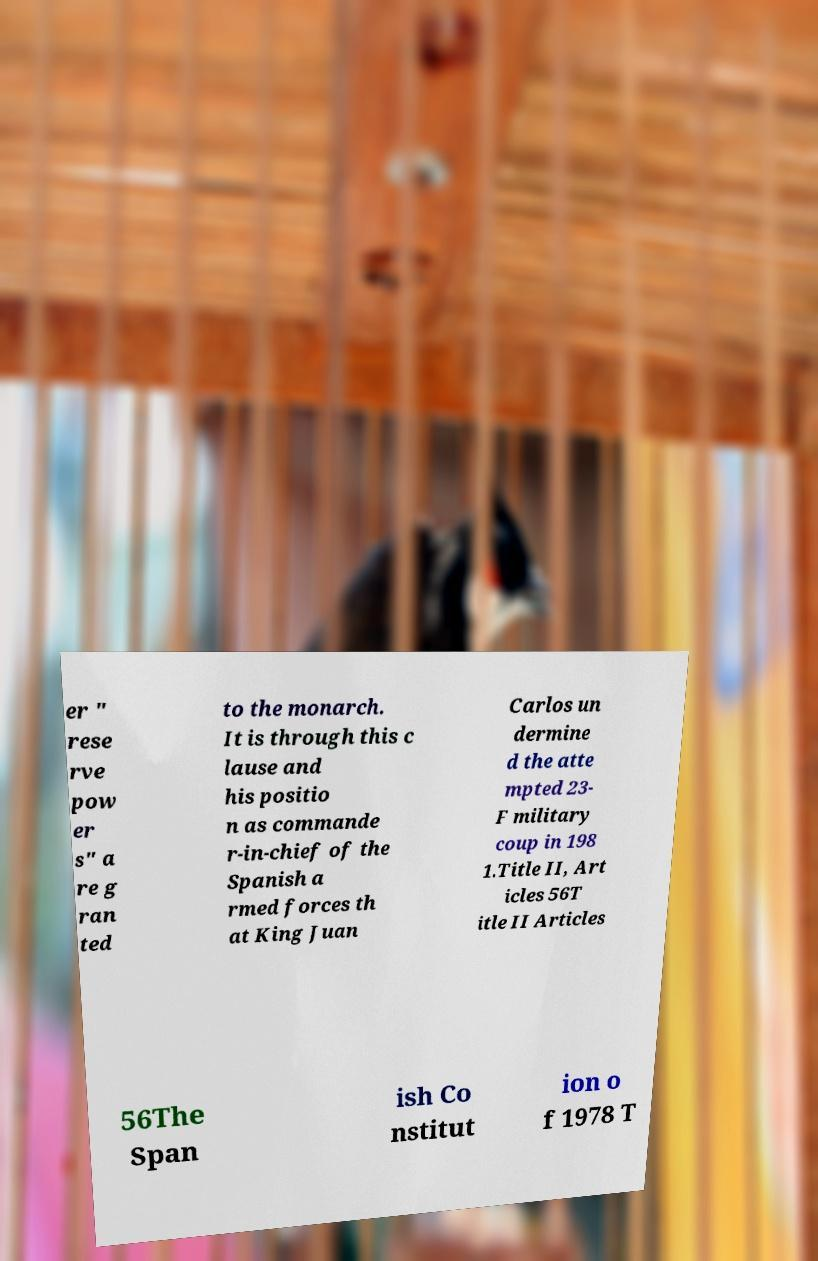What messages or text are displayed in this image? I need them in a readable, typed format. er " rese rve pow er s" a re g ran ted to the monarch. It is through this c lause and his positio n as commande r-in-chief of the Spanish a rmed forces th at King Juan Carlos un dermine d the atte mpted 23- F military coup in 198 1.Title II, Art icles 56T itle II Articles 56The Span ish Co nstitut ion o f 1978 T 